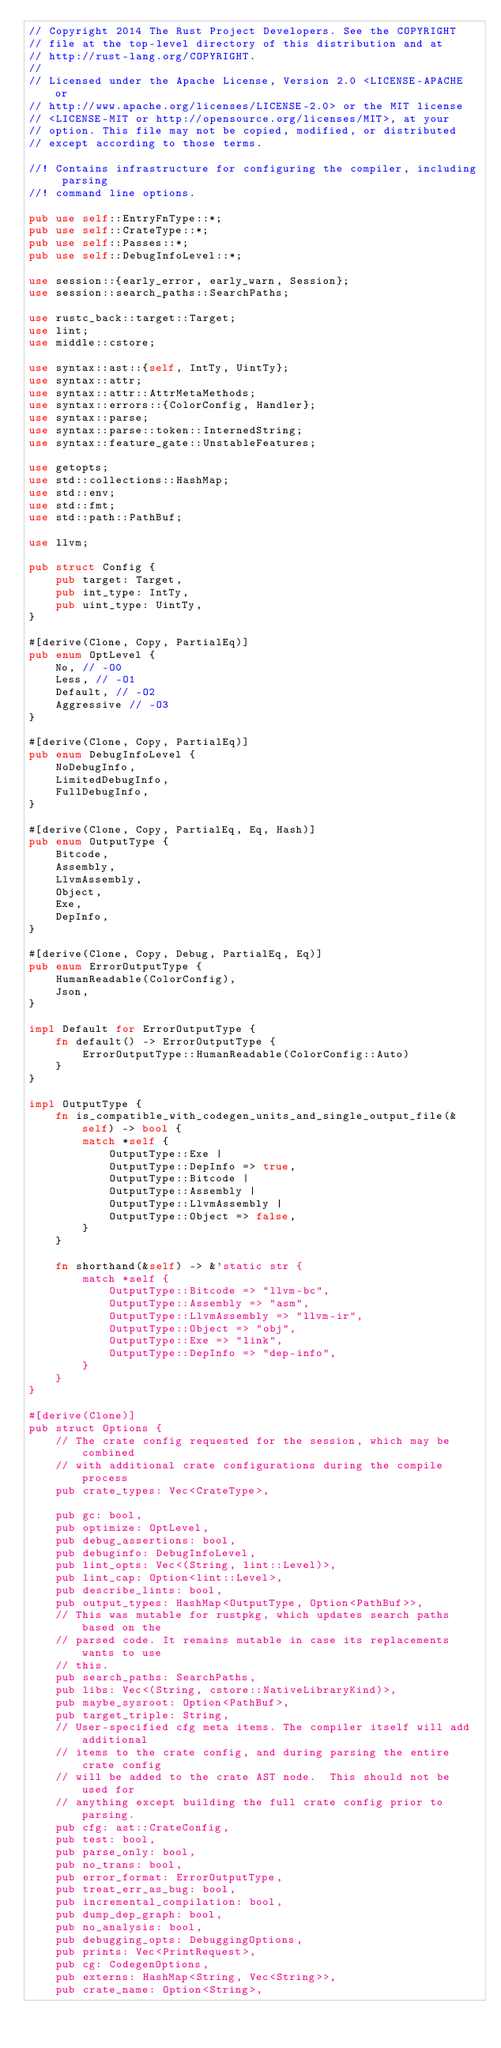<code> <loc_0><loc_0><loc_500><loc_500><_Rust_>// Copyright 2014 The Rust Project Developers. See the COPYRIGHT
// file at the top-level directory of this distribution and at
// http://rust-lang.org/COPYRIGHT.
//
// Licensed under the Apache License, Version 2.0 <LICENSE-APACHE or
// http://www.apache.org/licenses/LICENSE-2.0> or the MIT license
// <LICENSE-MIT or http://opensource.org/licenses/MIT>, at your
// option. This file may not be copied, modified, or distributed
// except according to those terms.

//! Contains infrastructure for configuring the compiler, including parsing
//! command line options.

pub use self::EntryFnType::*;
pub use self::CrateType::*;
pub use self::Passes::*;
pub use self::DebugInfoLevel::*;

use session::{early_error, early_warn, Session};
use session::search_paths::SearchPaths;

use rustc_back::target::Target;
use lint;
use middle::cstore;

use syntax::ast::{self, IntTy, UintTy};
use syntax::attr;
use syntax::attr::AttrMetaMethods;
use syntax::errors::{ColorConfig, Handler};
use syntax::parse;
use syntax::parse::token::InternedString;
use syntax::feature_gate::UnstableFeatures;

use getopts;
use std::collections::HashMap;
use std::env;
use std::fmt;
use std::path::PathBuf;

use llvm;

pub struct Config {
    pub target: Target,
    pub int_type: IntTy,
    pub uint_type: UintTy,
}

#[derive(Clone, Copy, PartialEq)]
pub enum OptLevel {
    No, // -O0
    Less, // -O1
    Default, // -O2
    Aggressive // -O3
}

#[derive(Clone, Copy, PartialEq)]
pub enum DebugInfoLevel {
    NoDebugInfo,
    LimitedDebugInfo,
    FullDebugInfo,
}

#[derive(Clone, Copy, PartialEq, Eq, Hash)]
pub enum OutputType {
    Bitcode,
    Assembly,
    LlvmAssembly,
    Object,
    Exe,
    DepInfo,
}

#[derive(Clone, Copy, Debug, PartialEq, Eq)]
pub enum ErrorOutputType {
    HumanReadable(ColorConfig),
    Json,
}

impl Default for ErrorOutputType {
    fn default() -> ErrorOutputType {
        ErrorOutputType::HumanReadable(ColorConfig::Auto)
    }
}

impl OutputType {
    fn is_compatible_with_codegen_units_and_single_output_file(&self) -> bool {
        match *self {
            OutputType::Exe |
            OutputType::DepInfo => true,
            OutputType::Bitcode |
            OutputType::Assembly |
            OutputType::LlvmAssembly |
            OutputType::Object => false,
        }
    }

    fn shorthand(&self) -> &'static str {
        match *self {
            OutputType::Bitcode => "llvm-bc",
            OutputType::Assembly => "asm",
            OutputType::LlvmAssembly => "llvm-ir",
            OutputType::Object => "obj",
            OutputType::Exe => "link",
            OutputType::DepInfo => "dep-info",
        }
    }
}

#[derive(Clone)]
pub struct Options {
    // The crate config requested for the session, which may be combined
    // with additional crate configurations during the compile process
    pub crate_types: Vec<CrateType>,

    pub gc: bool,
    pub optimize: OptLevel,
    pub debug_assertions: bool,
    pub debuginfo: DebugInfoLevel,
    pub lint_opts: Vec<(String, lint::Level)>,
    pub lint_cap: Option<lint::Level>,
    pub describe_lints: bool,
    pub output_types: HashMap<OutputType, Option<PathBuf>>,
    // This was mutable for rustpkg, which updates search paths based on the
    // parsed code. It remains mutable in case its replacements wants to use
    // this.
    pub search_paths: SearchPaths,
    pub libs: Vec<(String, cstore::NativeLibraryKind)>,
    pub maybe_sysroot: Option<PathBuf>,
    pub target_triple: String,
    // User-specified cfg meta items. The compiler itself will add additional
    // items to the crate config, and during parsing the entire crate config
    // will be added to the crate AST node.  This should not be used for
    // anything except building the full crate config prior to parsing.
    pub cfg: ast::CrateConfig,
    pub test: bool,
    pub parse_only: bool,
    pub no_trans: bool,
    pub error_format: ErrorOutputType,
    pub treat_err_as_bug: bool,
    pub incremental_compilation: bool,
    pub dump_dep_graph: bool,
    pub no_analysis: bool,
    pub debugging_opts: DebuggingOptions,
    pub prints: Vec<PrintRequest>,
    pub cg: CodegenOptions,
    pub externs: HashMap<String, Vec<String>>,
    pub crate_name: Option<String>,</code> 